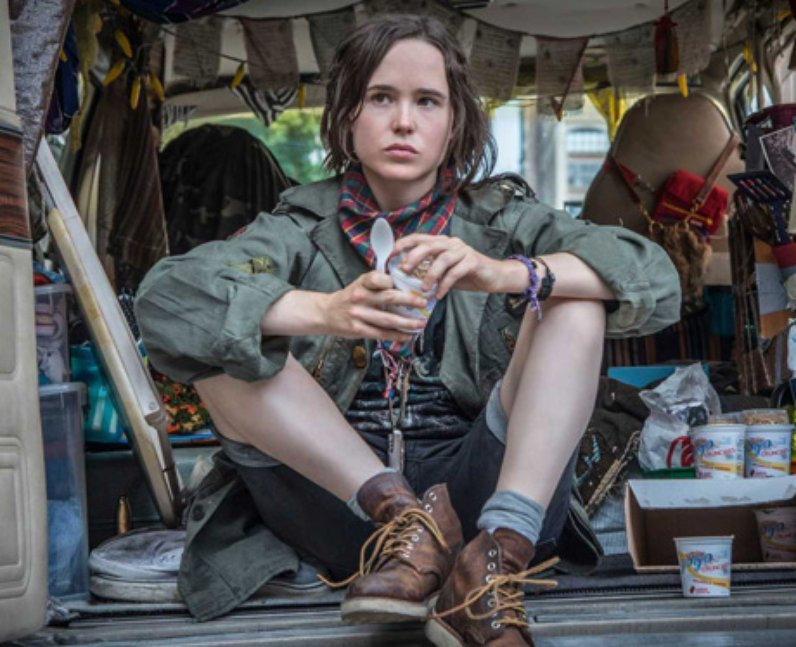Describe the lifestyle that this image suggests. The image suggests a nomadic or bohemian lifestyle, characterized by travel and living on the go. The van is cluttered with personal items, indicating that it serves as both a mode of transportation and a living space. The person’s attire and the eclectic decorations hint at a free-spirited, adventurous life. This lifestyle is often associated with a strong sense of independence and a willingness to embrace the unknown, as well as a desire to collect and cherish memories and mementos from various places visited. 